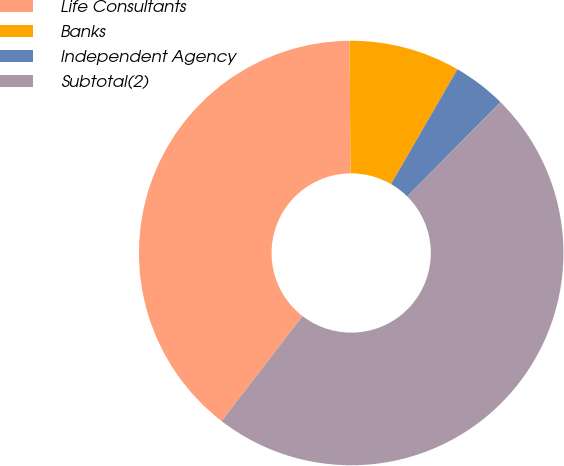<chart> <loc_0><loc_0><loc_500><loc_500><pie_chart><fcel>Life Consultants<fcel>Banks<fcel>Independent Agency<fcel>Subtotal(2)<nl><fcel>39.42%<fcel>8.47%<fcel>4.07%<fcel>48.04%<nl></chart> 